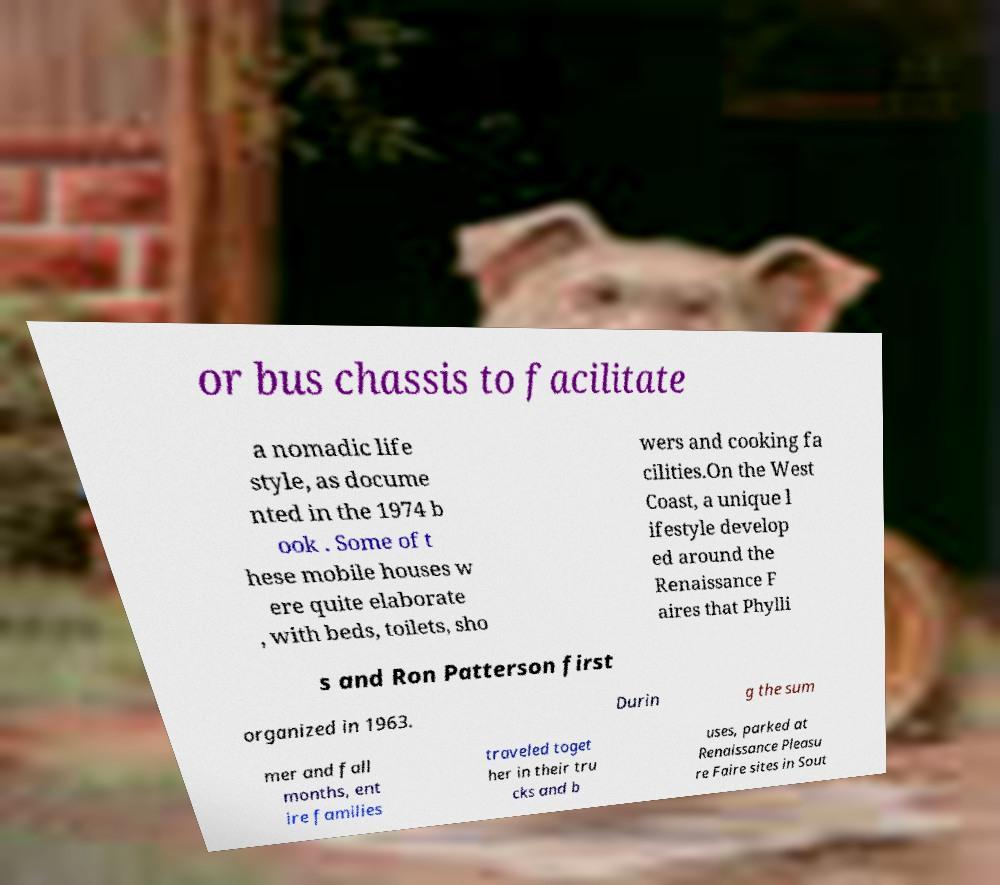Please read and relay the text visible in this image. What does it say? or bus chassis to facilitate a nomadic life style, as docume nted in the 1974 b ook . Some of t hese mobile houses w ere quite elaborate , with beds, toilets, sho wers and cooking fa cilities.On the West Coast, a unique l ifestyle develop ed around the Renaissance F aires that Phylli s and Ron Patterson first organized in 1963. Durin g the sum mer and fall months, ent ire families traveled toget her in their tru cks and b uses, parked at Renaissance Pleasu re Faire sites in Sout 